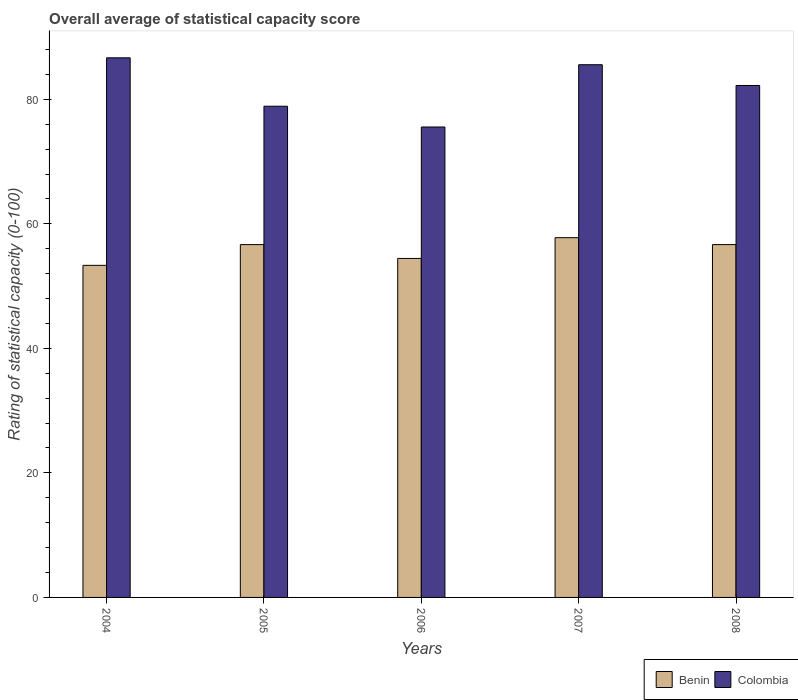Are the number of bars per tick equal to the number of legend labels?
Provide a short and direct response. Yes. Are the number of bars on each tick of the X-axis equal?
Your response must be concise. Yes. How many bars are there on the 5th tick from the left?
Give a very brief answer. 2. What is the label of the 4th group of bars from the left?
Keep it short and to the point. 2007. What is the rating of statistical capacity in Benin in 2007?
Your answer should be compact. 57.78. Across all years, what is the maximum rating of statistical capacity in Colombia?
Your answer should be very brief. 86.67. Across all years, what is the minimum rating of statistical capacity in Benin?
Offer a terse response. 53.33. In which year was the rating of statistical capacity in Benin minimum?
Give a very brief answer. 2004. What is the total rating of statistical capacity in Benin in the graph?
Ensure brevity in your answer.  278.89. What is the difference between the rating of statistical capacity in Benin in 2004 and that in 2007?
Make the answer very short. -4.44. What is the difference between the rating of statistical capacity in Colombia in 2006 and the rating of statistical capacity in Benin in 2004?
Provide a succinct answer. 22.22. What is the average rating of statistical capacity in Colombia per year?
Offer a terse response. 81.78. In the year 2005, what is the difference between the rating of statistical capacity in Benin and rating of statistical capacity in Colombia?
Ensure brevity in your answer.  -22.22. What is the ratio of the rating of statistical capacity in Colombia in 2005 to that in 2008?
Ensure brevity in your answer.  0.96. Is the rating of statistical capacity in Benin in 2006 less than that in 2008?
Your answer should be very brief. Yes. What is the difference between the highest and the second highest rating of statistical capacity in Colombia?
Offer a very short reply. 1.11. What is the difference between the highest and the lowest rating of statistical capacity in Colombia?
Provide a succinct answer. 11.11. Is the sum of the rating of statistical capacity in Colombia in 2005 and 2006 greater than the maximum rating of statistical capacity in Benin across all years?
Make the answer very short. Yes. What does the 2nd bar from the left in 2007 represents?
Your answer should be very brief. Colombia. What does the 2nd bar from the right in 2005 represents?
Keep it short and to the point. Benin. How many bars are there?
Your response must be concise. 10. What is the difference between two consecutive major ticks on the Y-axis?
Ensure brevity in your answer.  20. Where does the legend appear in the graph?
Keep it short and to the point. Bottom right. How are the legend labels stacked?
Your answer should be compact. Horizontal. What is the title of the graph?
Your answer should be compact. Overall average of statistical capacity score. Does "Mongolia" appear as one of the legend labels in the graph?
Keep it short and to the point. No. What is the label or title of the Y-axis?
Give a very brief answer. Rating of statistical capacity (0-100). What is the Rating of statistical capacity (0-100) in Benin in 2004?
Your answer should be compact. 53.33. What is the Rating of statistical capacity (0-100) in Colombia in 2004?
Offer a very short reply. 86.67. What is the Rating of statistical capacity (0-100) in Benin in 2005?
Your answer should be compact. 56.67. What is the Rating of statistical capacity (0-100) of Colombia in 2005?
Give a very brief answer. 78.89. What is the Rating of statistical capacity (0-100) in Benin in 2006?
Your answer should be compact. 54.44. What is the Rating of statistical capacity (0-100) of Colombia in 2006?
Your response must be concise. 75.56. What is the Rating of statistical capacity (0-100) in Benin in 2007?
Provide a succinct answer. 57.78. What is the Rating of statistical capacity (0-100) of Colombia in 2007?
Offer a terse response. 85.56. What is the Rating of statistical capacity (0-100) of Benin in 2008?
Make the answer very short. 56.67. What is the Rating of statistical capacity (0-100) in Colombia in 2008?
Your answer should be compact. 82.22. Across all years, what is the maximum Rating of statistical capacity (0-100) of Benin?
Offer a terse response. 57.78. Across all years, what is the maximum Rating of statistical capacity (0-100) in Colombia?
Your answer should be very brief. 86.67. Across all years, what is the minimum Rating of statistical capacity (0-100) in Benin?
Your response must be concise. 53.33. Across all years, what is the minimum Rating of statistical capacity (0-100) of Colombia?
Provide a short and direct response. 75.56. What is the total Rating of statistical capacity (0-100) in Benin in the graph?
Your answer should be very brief. 278.89. What is the total Rating of statistical capacity (0-100) of Colombia in the graph?
Provide a short and direct response. 408.89. What is the difference between the Rating of statistical capacity (0-100) in Benin in 2004 and that in 2005?
Provide a succinct answer. -3.33. What is the difference between the Rating of statistical capacity (0-100) in Colombia in 2004 and that in 2005?
Your response must be concise. 7.78. What is the difference between the Rating of statistical capacity (0-100) of Benin in 2004 and that in 2006?
Offer a terse response. -1.11. What is the difference between the Rating of statistical capacity (0-100) of Colombia in 2004 and that in 2006?
Provide a succinct answer. 11.11. What is the difference between the Rating of statistical capacity (0-100) of Benin in 2004 and that in 2007?
Your answer should be compact. -4.44. What is the difference between the Rating of statistical capacity (0-100) of Colombia in 2004 and that in 2008?
Give a very brief answer. 4.44. What is the difference between the Rating of statistical capacity (0-100) in Benin in 2005 and that in 2006?
Your answer should be very brief. 2.22. What is the difference between the Rating of statistical capacity (0-100) in Colombia in 2005 and that in 2006?
Keep it short and to the point. 3.33. What is the difference between the Rating of statistical capacity (0-100) in Benin in 2005 and that in 2007?
Offer a terse response. -1.11. What is the difference between the Rating of statistical capacity (0-100) in Colombia in 2005 and that in 2007?
Your answer should be very brief. -6.67. What is the difference between the Rating of statistical capacity (0-100) of Colombia in 2005 and that in 2008?
Give a very brief answer. -3.33. What is the difference between the Rating of statistical capacity (0-100) in Benin in 2006 and that in 2007?
Ensure brevity in your answer.  -3.33. What is the difference between the Rating of statistical capacity (0-100) of Benin in 2006 and that in 2008?
Offer a very short reply. -2.22. What is the difference between the Rating of statistical capacity (0-100) in Colombia in 2006 and that in 2008?
Provide a short and direct response. -6.67. What is the difference between the Rating of statistical capacity (0-100) in Benin in 2007 and that in 2008?
Offer a terse response. 1.11. What is the difference between the Rating of statistical capacity (0-100) in Benin in 2004 and the Rating of statistical capacity (0-100) in Colombia in 2005?
Your response must be concise. -25.56. What is the difference between the Rating of statistical capacity (0-100) of Benin in 2004 and the Rating of statistical capacity (0-100) of Colombia in 2006?
Give a very brief answer. -22.22. What is the difference between the Rating of statistical capacity (0-100) of Benin in 2004 and the Rating of statistical capacity (0-100) of Colombia in 2007?
Your response must be concise. -32.22. What is the difference between the Rating of statistical capacity (0-100) in Benin in 2004 and the Rating of statistical capacity (0-100) in Colombia in 2008?
Offer a terse response. -28.89. What is the difference between the Rating of statistical capacity (0-100) in Benin in 2005 and the Rating of statistical capacity (0-100) in Colombia in 2006?
Ensure brevity in your answer.  -18.89. What is the difference between the Rating of statistical capacity (0-100) in Benin in 2005 and the Rating of statistical capacity (0-100) in Colombia in 2007?
Ensure brevity in your answer.  -28.89. What is the difference between the Rating of statistical capacity (0-100) in Benin in 2005 and the Rating of statistical capacity (0-100) in Colombia in 2008?
Offer a very short reply. -25.56. What is the difference between the Rating of statistical capacity (0-100) in Benin in 2006 and the Rating of statistical capacity (0-100) in Colombia in 2007?
Offer a terse response. -31.11. What is the difference between the Rating of statistical capacity (0-100) of Benin in 2006 and the Rating of statistical capacity (0-100) of Colombia in 2008?
Ensure brevity in your answer.  -27.78. What is the difference between the Rating of statistical capacity (0-100) in Benin in 2007 and the Rating of statistical capacity (0-100) in Colombia in 2008?
Your answer should be compact. -24.44. What is the average Rating of statistical capacity (0-100) in Benin per year?
Offer a very short reply. 55.78. What is the average Rating of statistical capacity (0-100) in Colombia per year?
Provide a short and direct response. 81.78. In the year 2004, what is the difference between the Rating of statistical capacity (0-100) of Benin and Rating of statistical capacity (0-100) of Colombia?
Give a very brief answer. -33.33. In the year 2005, what is the difference between the Rating of statistical capacity (0-100) in Benin and Rating of statistical capacity (0-100) in Colombia?
Your answer should be compact. -22.22. In the year 2006, what is the difference between the Rating of statistical capacity (0-100) in Benin and Rating of statistical capacity (0-100) in Colombia?
Offer a very short reply. -21.11. In the year 2007, what is the difference between the Rating of statistical capacity (0-100) of Benin and Rating of statistical capacity (0-100) of Colombia?
Provide a short and direct response. -27.78. In the year 2008, what is the difference between the Rating of statistical capacity (0-100) of Benin and Rating of statistical capacity (0-100) of Colombia?
Ensure brevity in your answer.  -25.56. What is the ratio of the Rating of statistical capacity (0-100) in Colombia in 2004 to that in 2005?
Provide a succinct answer. 1.1. What is the ratio of the Rating of statistical capacity (0-100) in Benin in 2004 to that in 2006?
Your answer should be very brief. 0.98. What is the ratio of the Rating of statistical capacity (0-100) in Colombia in 2004 to that in 2006?
Provide a short and direct response. 1.15. What is the ratio of the Rating of statistical capacity (0-100) in Benin in 2004 to that in 2007?
Offer a very short reply. 0.92. What is the ratio of the Rating of statistical capacity (0-100) in Colombia in 2004 to that in 2007?
Keep it short and to the point. 1.01. What is the ratio of the Rating of statistical capacity (0-100) in Colombia in 2004 to that in 2008?
Give a very brief answer. 1.05. What is the ratio of the Rating of statistical capacity (0-100) of Benin in 2005 to that in 2006?
Your response must be concise. 1.04. What is the ratio of the Rating of statistical capacity (0-100) in Colombia in 2005 to that in 2006?
Your response must be concise. 1.04. What is the ratio of the Rating of statistical capacity (0-100) in Benin in 2005 to that in 2007?
Ensure brevity in your answer.  0.98. What is the ratio of the Rating of statistical capacity (0-100) of Colombia in 2005 to that in 2007?
Provide a succinct answer. 0.92. What is the ratio of the Rating of statistical capacity (0-100) in Colombia in 2005 to that in 2008?
Offer a terse response. 0.96. What is the ratio of the Rating of statistical capacity (0-100) of Benin in 2006 to that in 2007?
Provide a short and direct response. 0.94. What is the ratio of the Rating of statistical capacity (0-100) of Colombia in 2006 to that in 2007?
Offer a terse response. 0.88. What is the ratio of the Rating of statistical capacity (0-100) of Benin in 2006 to that in 2008?
Make the answer very short. 0.96. What is the ratio of the Rating of statistical capacity (0-100) in Colombia in 2006 to that in 2008?
Ensure brevity in your answer.  0.92. What is the ratio of the Rating of statistical capacity (0-100) in Benin in 2007 to that in 2008?
Your response must be concise. 1.02. What is the ratio of the Rating of statistical capacity (0-100) of Colombia in 2007 to that in 2008?
Your answer should be very brief. 1.04. What is the difference between the highest and the second highest Rating of statistical capacity (0-100) of Benin?
Make the answer very short. 1.11. What is the difference between the highest and the second highest Rating of statistical capacity (0-100) in Colombia?
Give a very brief answer. 1.11. What is the difference between the highest and the lowest Rating of statistical capacity (0-100) of Benin?
Provide a succinct answer. 4.44. What is the difference between the highest and the lowest Rating of statistical capacity (0-100) in Colombia?
Give a very brief answer. 11.11. 